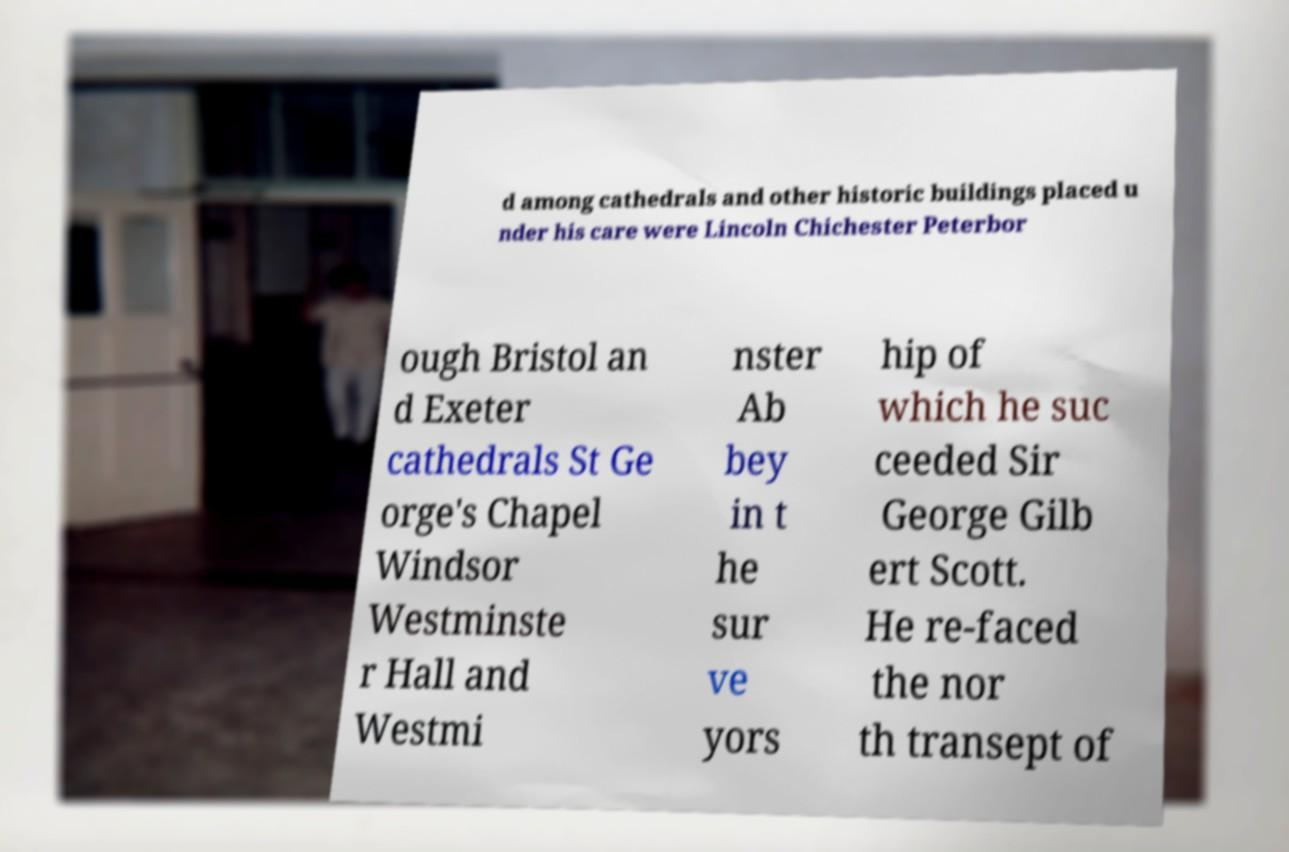I need the written content from this picture converted into text. Can you do that? d among cathedrals and other historic buildings placed u nder his care were Lincoln Chichester Peterbor ough Bristol an d Exeter cathedrals St Ge orge's Chapel Windsor Westminste r Hall and Westmi nster Ab bey in t he sur ve yors hip of which he suc ceeded Sir George Gilb ert Scott. He re-faced the nor th transept of 